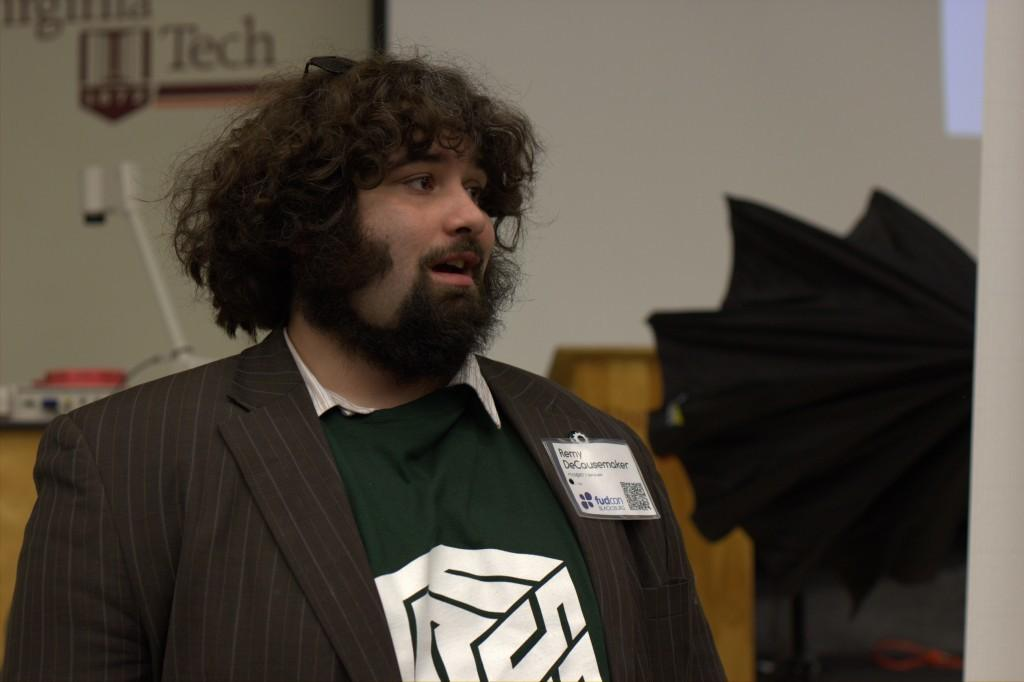Who is present in the image? There is a man in the image. What object is visible in the image that might be used for protection from the elements? There is an umbrella visible in the image. What object is present in the image that might be used for amplifying sound? There is a speaker stand in the image. What can be seen on a table in the image? There are objects on a table in the image. What is written on the board that is visible on a wall in the image? There is a board on a wall with text in the image. Can you describe the ghost that is present in the image? There is no ghost present in the image. What type of acoustics can be observed in the image? The image does not provide information about the acoustics of the environment. 